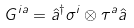<formula> <loc_0><loc_0><loc_500><loc_500>G ^ { i a } = \hat { a } ^ { \dagger } \sigma ^ { i } \otimes \tau ^ { a } \hat { a }</formula> 